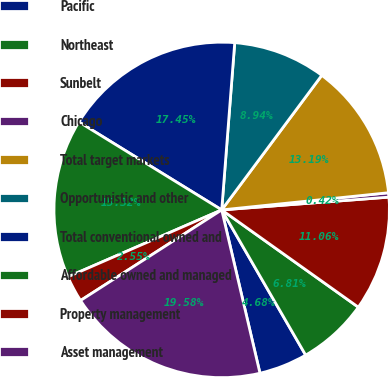Convert chart. <chart><loc_0><loc_0><loc_500><loc_500><pie_chart><fcel>Pacific<fcel>Northeast<fcel>Sunbelt<fcel>Chicago<fcel>Total target markets<fcel>Opportunistic and other<fcel>Total conventional owned and<fcel>Affordable owned and managed<fcel>Property management<fcel>Asset management<nl><fcel>4.68%<fcel>6.81%<fcel>11.06%<fcel>0.42%<fcel>13.19%<fcel>8.94%<fcel>17.45%<fcel>15.32%<fcel>2.55%<fcel>19.58%<nl></chart> 